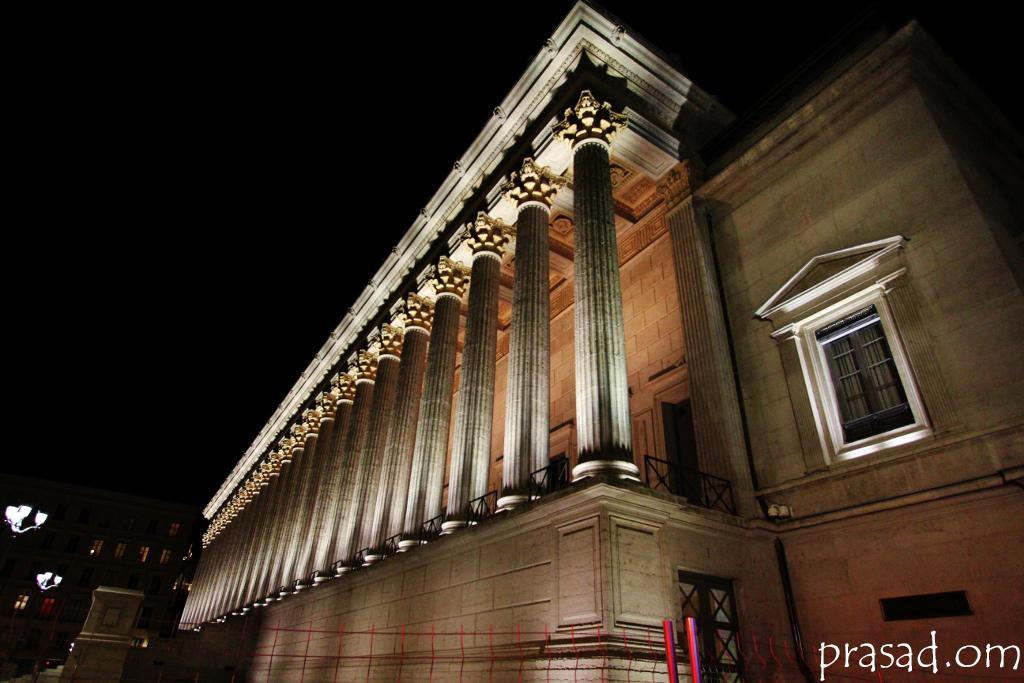What type of structures can be seen in the image? There are buildings in the image. What else is visible in the image besides the buildings? There are lights and a fence visible in the image. Is there any text present in the image? Yes, there is text at the bottom of the image. What type of beef is being prepared in the image? There is no beef present in the image. What emotion can be seen on the faces of the people in the image? There are no people present in the image, so their emotions cannot be determined. 